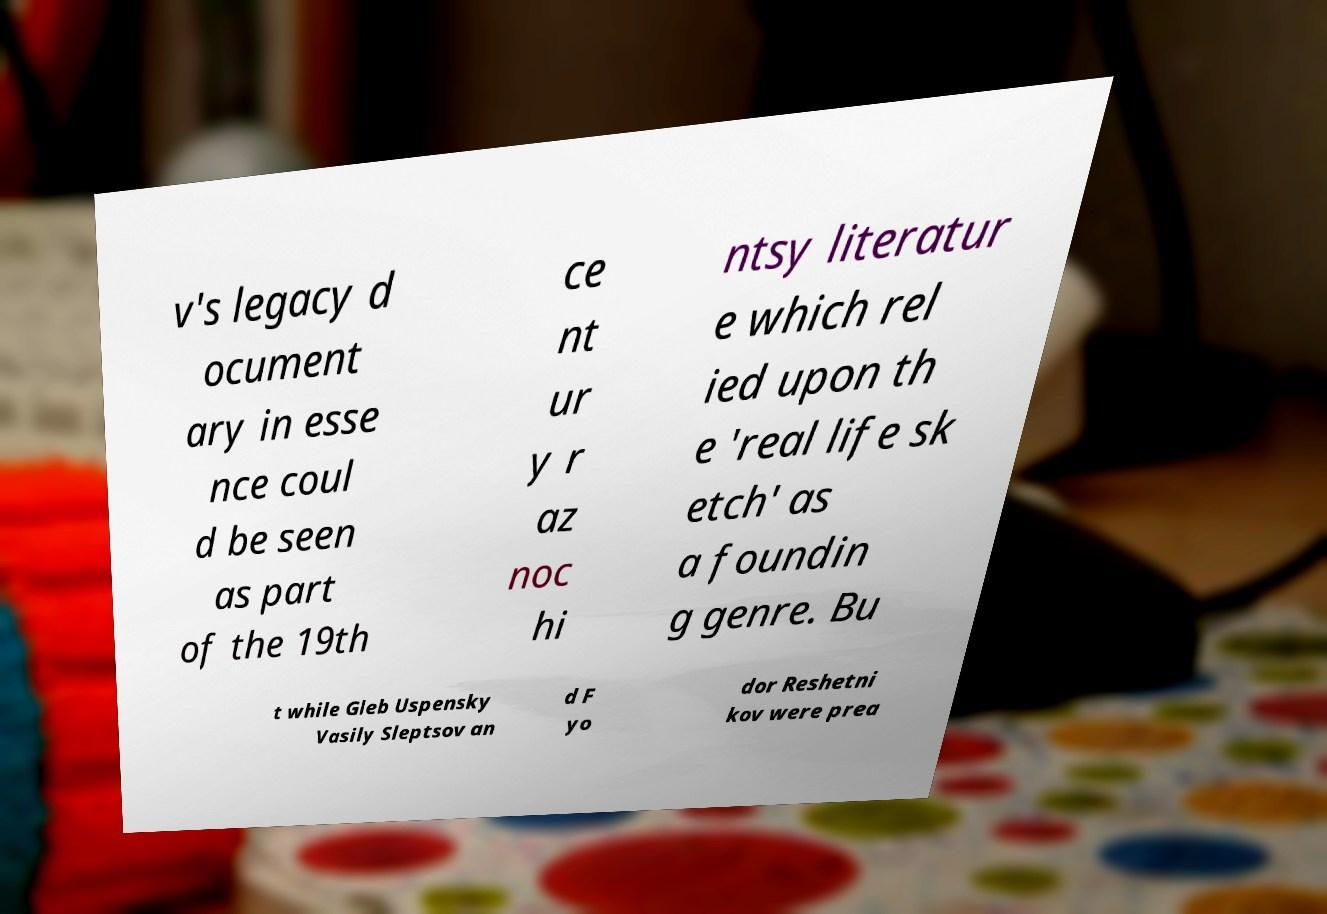Please read and relay the text visible in this image. What does it say? v's legacy d ocument ary in esse nce coul d be seen as part of the 19th ce nt ur y r az noc hi ntsy literatur e which rel ied upon th e 'real life sk etch' as a foundin g genre. Bu t while Gleb Uspensky Vasily Sleptsov an d F yo dor Reshetni kov were prea 